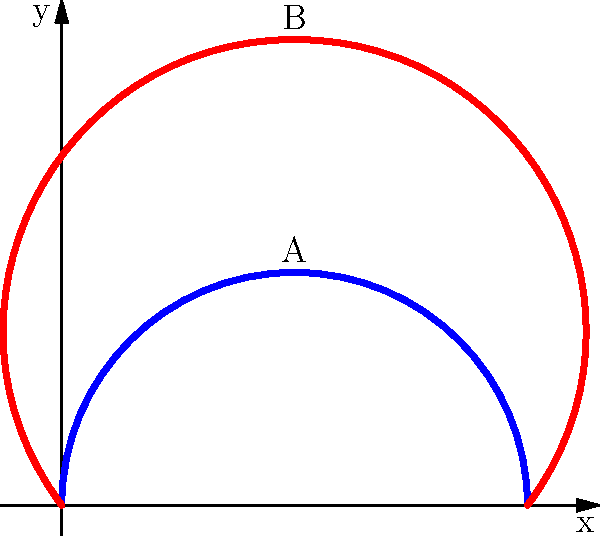Consider two horseshoe shapes commonly found in country music imagery, represented by the blue curve A and the red curve B. Are these two horseshoe shapes homotopy equivalent? If so, describe a continuous deformation from one to the other. If not, explain why. To determine if the two horseshoe shapes are homotopy equivalent, we need to follow these steps:

1. Understand homotopy equivalence: Two shapes are homotopy equivalent if one can be continuously deformed into the other without cutting or gluing.

2. Analyze the shapes:
   - Both curves are continuous and have the same endpoints (0,0) and (2,0).
   - They differ only in the height of their arches.

3. Consider the deformation:
   - We can continuously deform curve A into curve B by gradually increasing the height of its arch.
   - This deformation can be described mathematically as:
     $$f_t(x, y) = (x, (1-t)y_A + ty_B)$$
     where $t \in [0,1]$, and $y_A$ and $y_B$ are the y-coordinates of curves A and B respectively.

4. Verify continuity:
   - The function $f_t$ is continuous in both $x$ and $t$.
   - At $t=0$, we have curve A, and at $t=1$, we have curve B.

5. Confirm bijection:
   - For each $t$, $f_t$ provides a bijection between the points on curve A and the corresponding points on the intermediate curve.

6. Inverse deformation:
   - We can also continuously deform curve B back into curve A using the inverse of the above function.

Therefore, the two horseshoe shapes are homotopy equivalent as we can continuously deform one into the other and vice versa.
Answer: Yes, homotopy equivalent. 